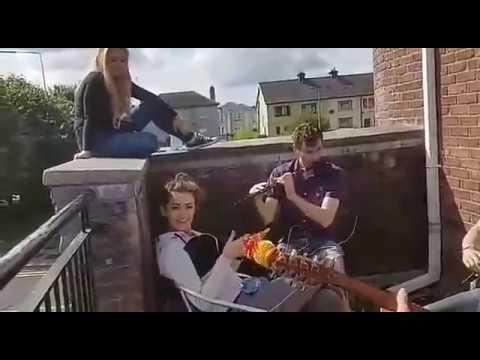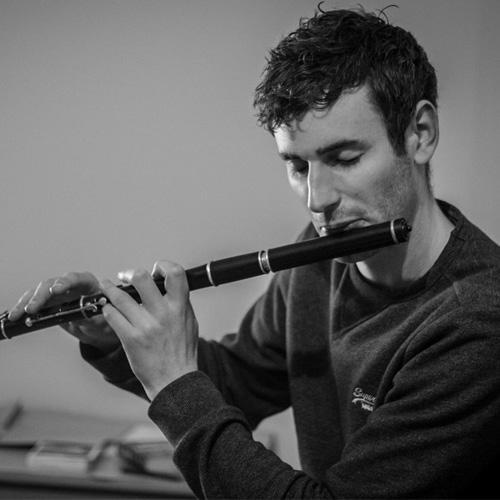The first image is the image on the left, the second image is the image on the right. Considering the images on both sides, is "There are five people with instruments." valid? Answer yes or no. No. The first image is the image on the left, the second image is the image on the right. For the images shown, is this caption "Two people are playing the flute." true? Answer yes or no. Yes. 